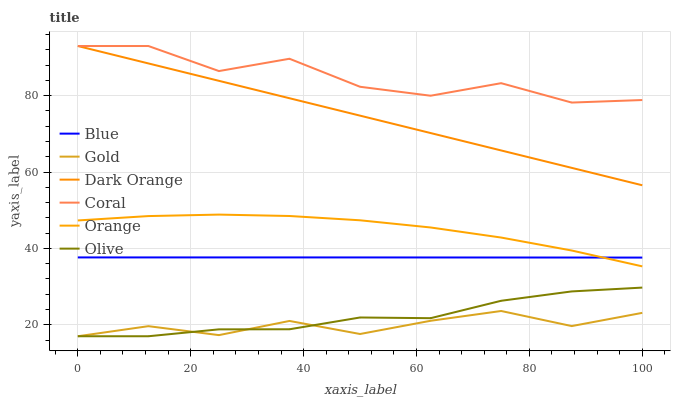Does Gold have the minimum area under the curve?
Answer yes or no. Yes. Does Coral have the maximum area under the curve?
Answer yes or no. Yes. Does Dark Orange have the minimum area under the curve?
Answer yes or no. No. Does Dark Orange have the maximum area under the curve?
Answer yes or no. No. Is Dark Orange the smoothest?
Answer yes or no. Yes. Is Coral the roughest?
Answer yes or no. Yes. Is Gold the smoothest?
Answer yes or no. No. Is Gold the roughest?
Answer yes or no. No. Does Gold have the lowest value?
Answer yes or no. Yes. Does Dark Orange have the lowest value?
Answer yes or no. No. Does Coral have the highest value?
Answer yes or no. Yes. Does Gold have the highest value?
Answer yes or no. No. Is Gold less than Dark Orange?
Answer yes or no. Yes. Is Blue greater than Gold?
Answer yes or no. Yes. Does Coral intersect Dark Orange?
Answer yes or no. Yes. Is Coral less than Dark Orange?
Answer yes or no. No. Is Coral greater than Dark Orange?
Answer yes or no. No. Does Gold intersect Dark Orange?
Answer yes or no. No. 